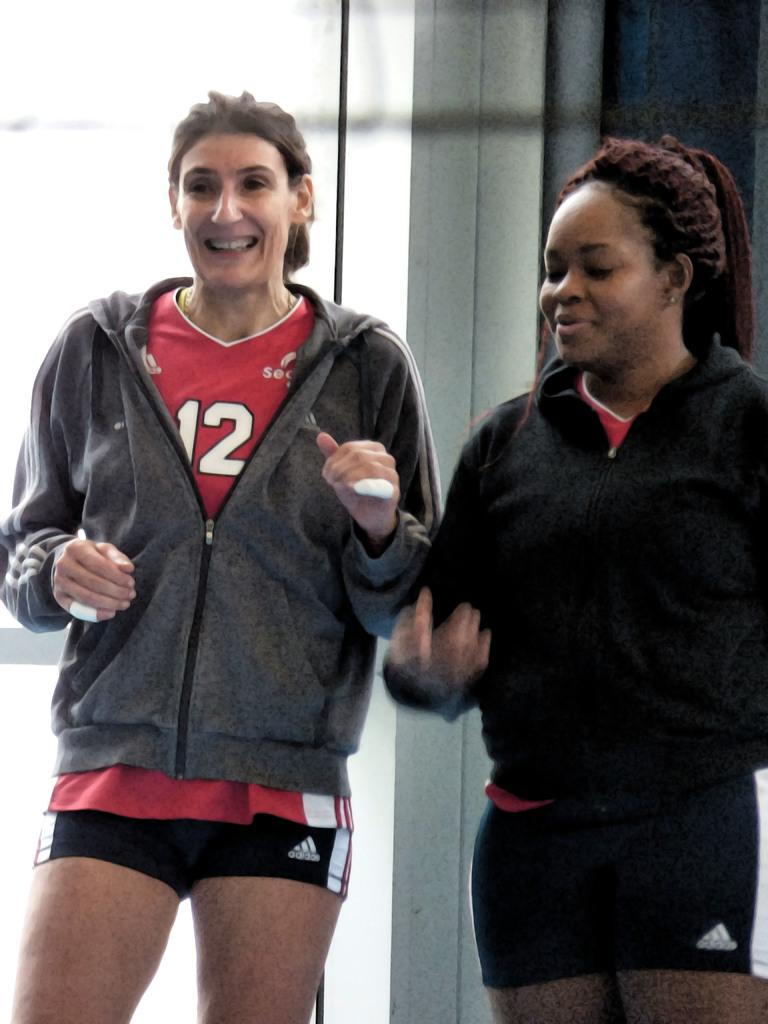<image>
Offer a succinct explanation of the picture presented. the number 12 is on the shirt of a girl 